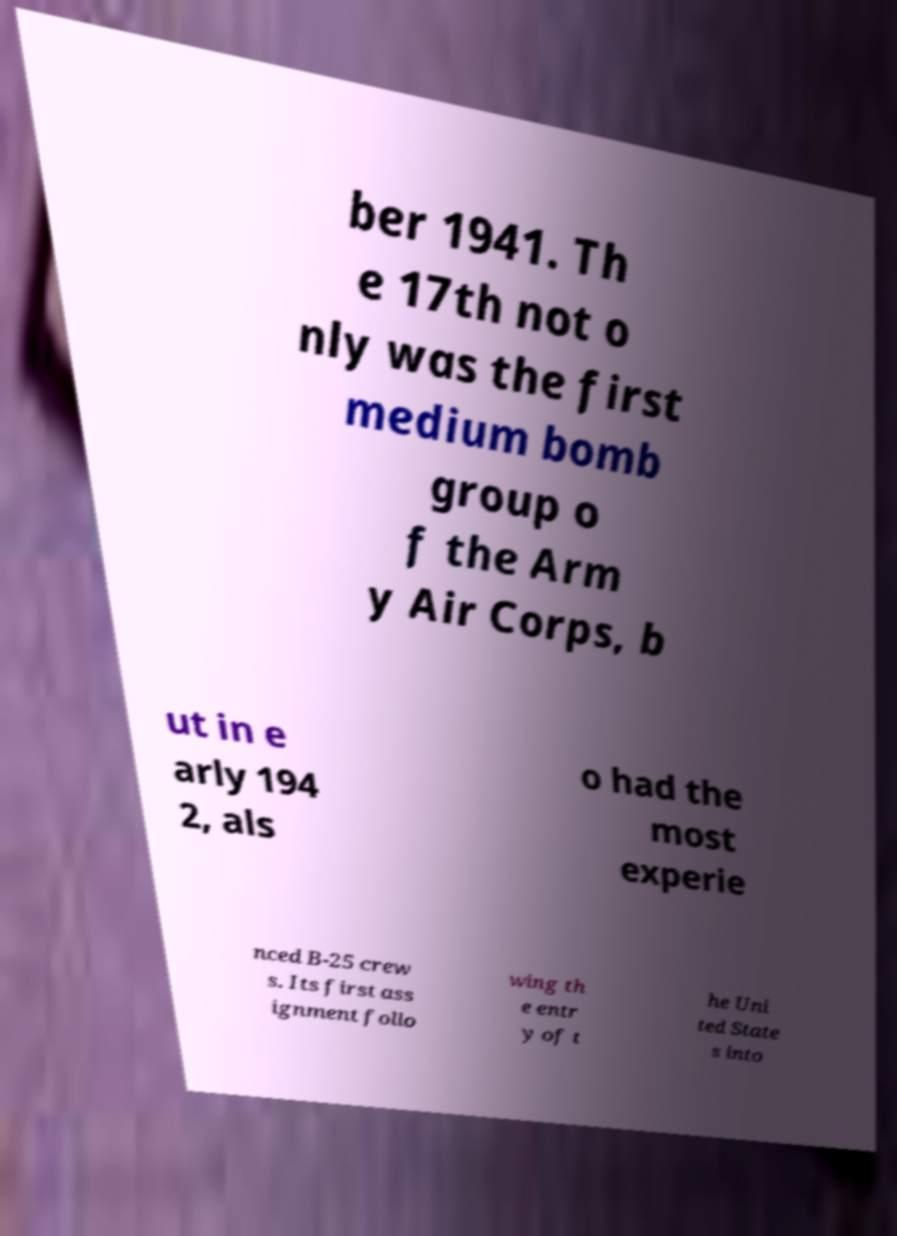Please read and relay the text visible in this image. What does it say? ber 1941. Th e 17th not o nly was the first medium bomb group o f the Arm y Air Corps, b ut in e arly 194 2, als o had the most experie nced B-25 crew s. Its first ass ignment follo wing th e entr y of t he Uni ted State s into 